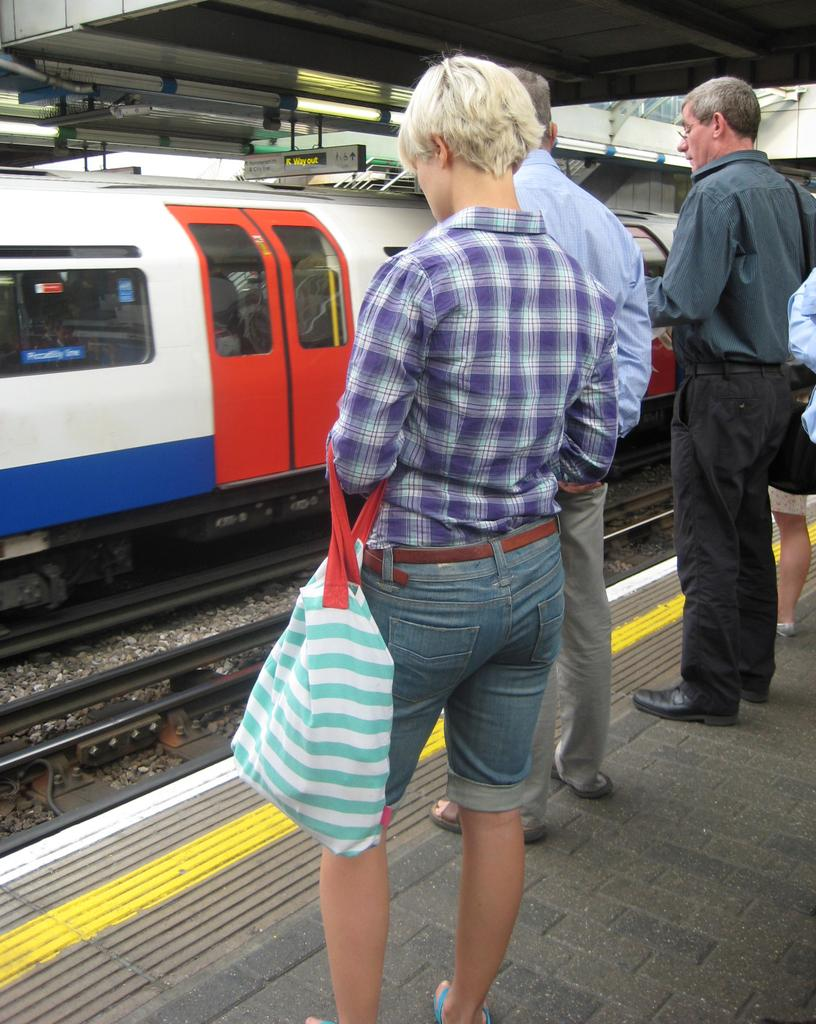How many people are in the image? There are people standing in the image. What is the person in the center holding? The person in the center is holding a bag. What can be seen in the background of the image? There is a train visible in the background of the image. What is the train's position in relation to the ground? The train is on a track. What is at the bottom of the image? There is a platform at the bottom of the image. What type of notebook is the person in the center using to write down their thoughts? There is no notebook present in the image, and the person in the center is not shown writing anything. 